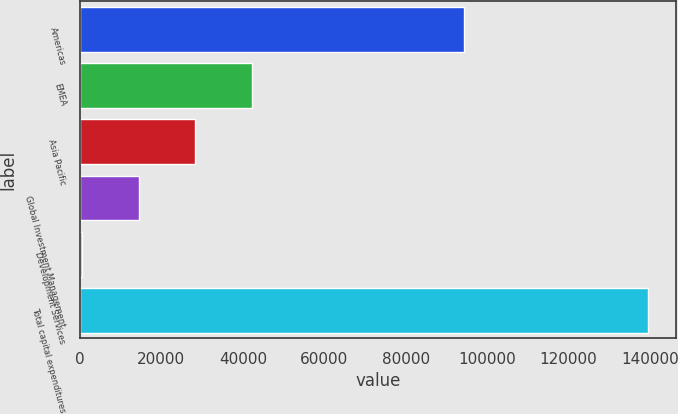Convert chart to OTSL. <chart><loc_0><loc_0><loc_500><loc_500><bar_chart><fcel>Americas<fcel>EMEA<fcel>Asia Pacific<fcel>Global Investment Management<fcel>Development Services<fcel>Total capital expenditures<nl><fcel>94376<fcel>42208.1<fcel>28314.4<fcel>14420.7<fcel>527<fcel>139464<nl></chart> 